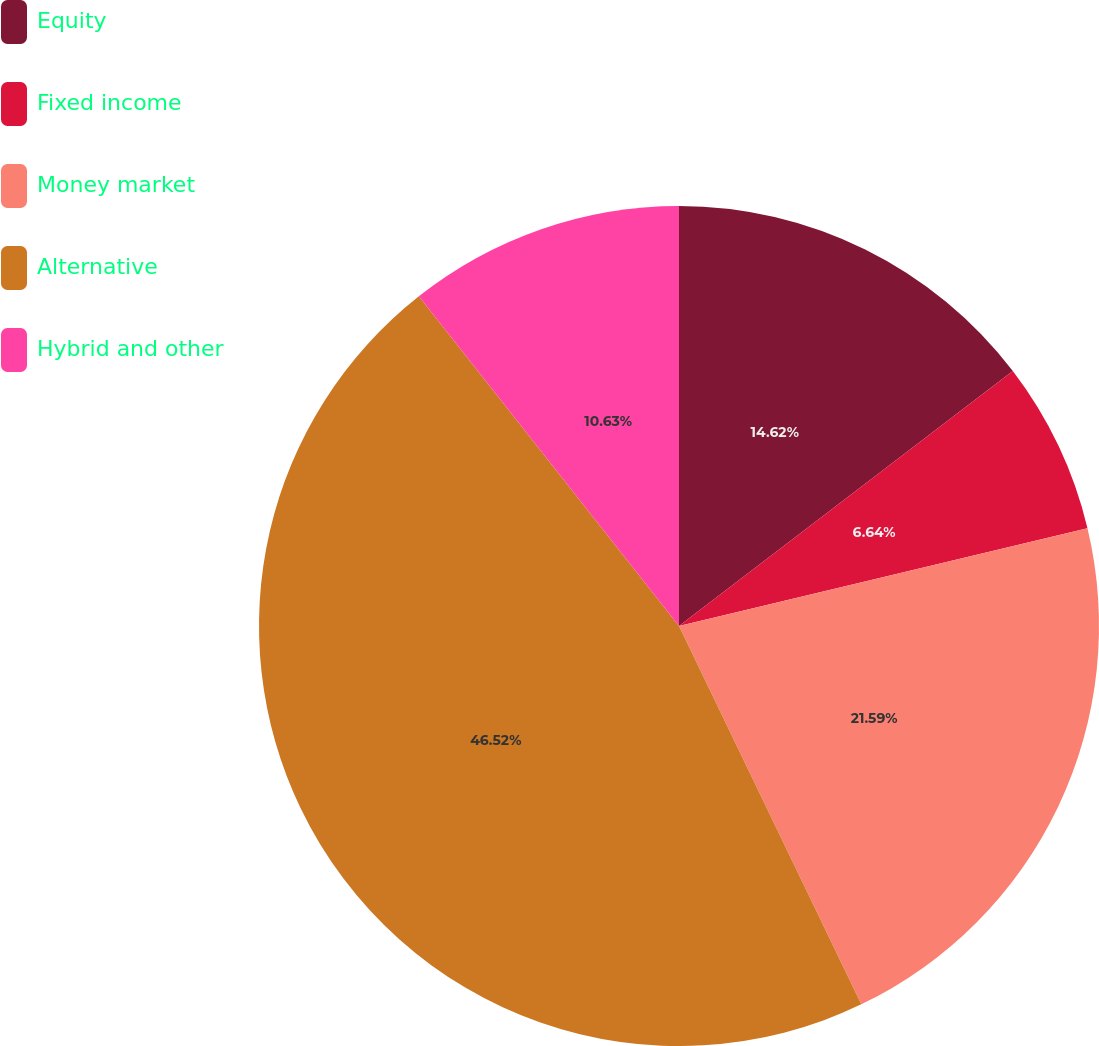<chart> <loc_0><loc_0><loc_500><loc_500><pie_chart><fcel>Equity<fcel>Fixed income<fcel>Money market<fcel>Alternative<fcel>Hybrid and other<nl><fcel>14.62%<fcel>6.64%<fcel>21.59%<fcel>46.51%<fcel>10.63%<nl></chart> 